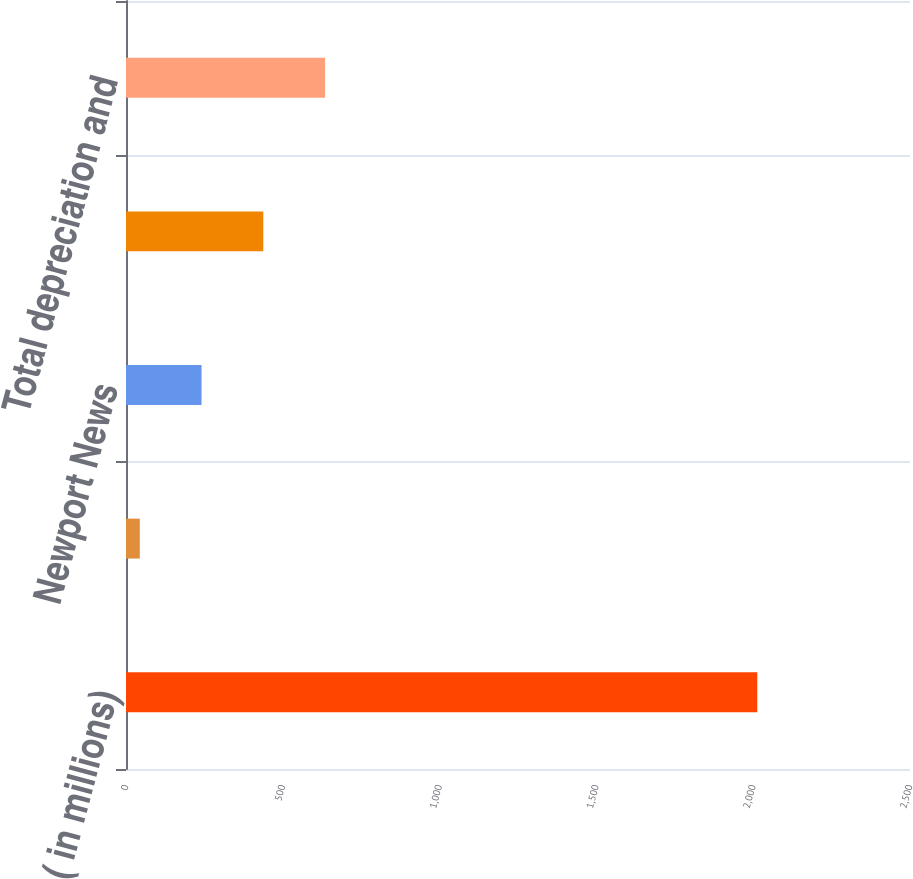Convert chart to OTSL. <chart><loc_0><loc_0><loc_500><loc_500><bar_chart><fcel>( in millions)<fcel>Ingalls<fcel>Newport News<fcel>Total capital expenditures<fcel>Total depreciation and<nl><fcel>2013<fcel>44<fcel>240.9<fcel>437.8<fcel>634.7<nl></chart> 